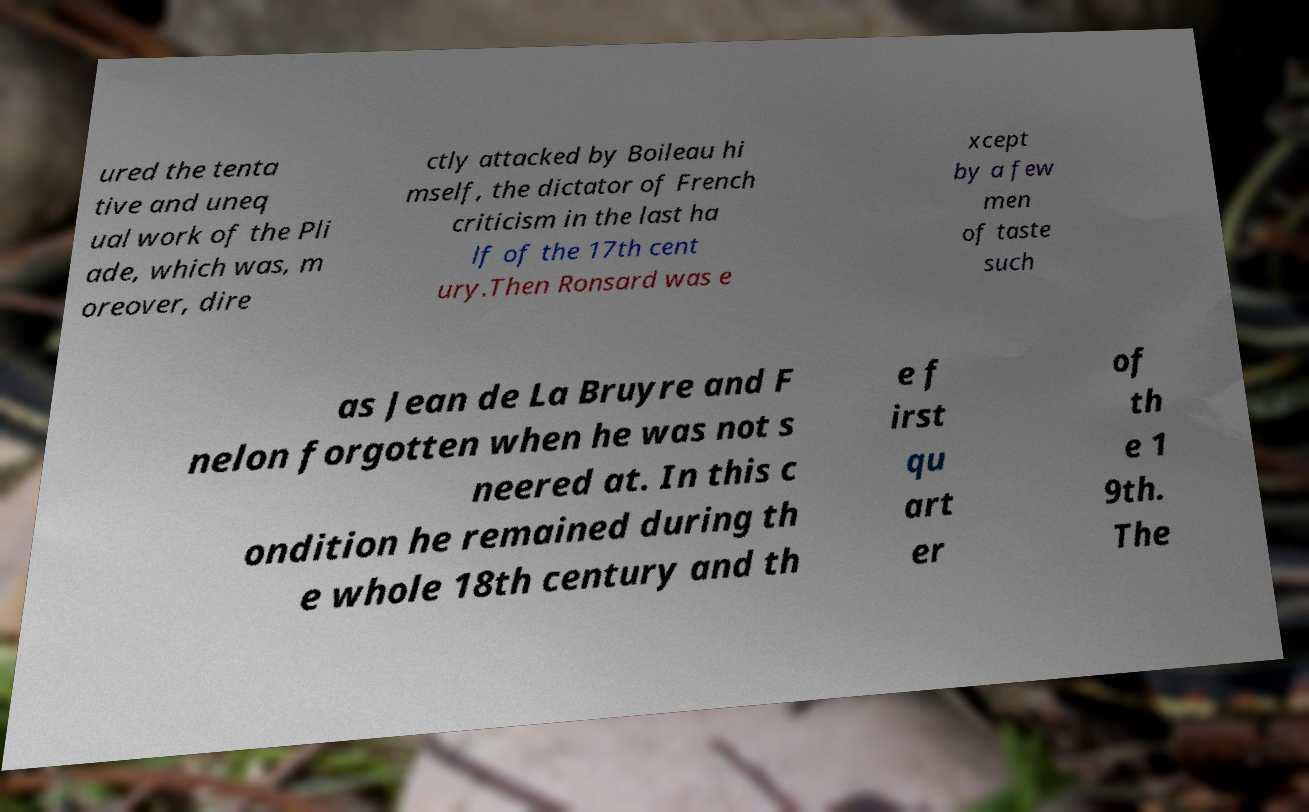I need the written content from this picture converted into text. Can you do that? ured the tenta tive and uneq ual work of the Pli ade, which was, m oreover, dire ctly attacked by Boileau hi mself, the dictator of French criticism in the last ha lf of the 17th cent ury.Then Ronsard was e xcept by a few men of taste such as Jean de La Bruyre and F nelon forgotten when he was not s neered at. In this c ondition he remained during th e whole 18th century and th e f irst qu art er of th e 1 9th. The 